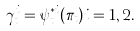Convert formula to latex. <formula><loc_0><loc_0><loc_500><loc_500>\gamma ^ { i } _ { t } = \psi ^ { * i } _ { t } ( \pi _ { t } ) i = 1 , 2 .</formula> 